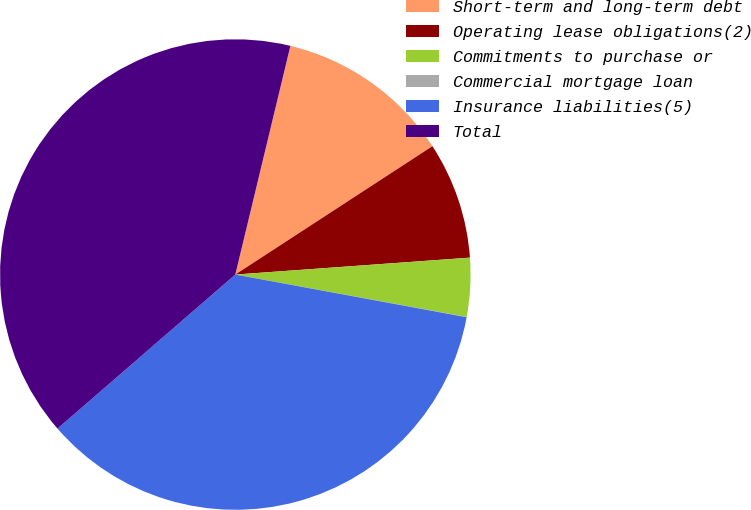Convert chart. <chart><loc_0><loc_0><loc_500><loc_500><pie_chart><fcel>Short-term and long-term debt<fcel>Operating lease obligations(2)<fcel>Commitments to purchase or<fcel>Commercial mortgage loan<fcel>Insurance liabilities(5)<fcel>Total<nl><fcel>12.05%<fcel>8.04%<fcel>4.03%<fcel>0.02%<fcel>35.73%<fcel>40.12%<nl></chart> 